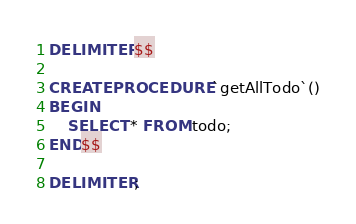Convert code to text. <code><loc_0><loc_0><loc_500><loc_500><_SQL_>DELIMITER $$
 
CREATE PROCEDURE `getAllTodo`()
BEGIN
    SELECT * FROM todo;
END$$
 
DELIMITER ;</code> 